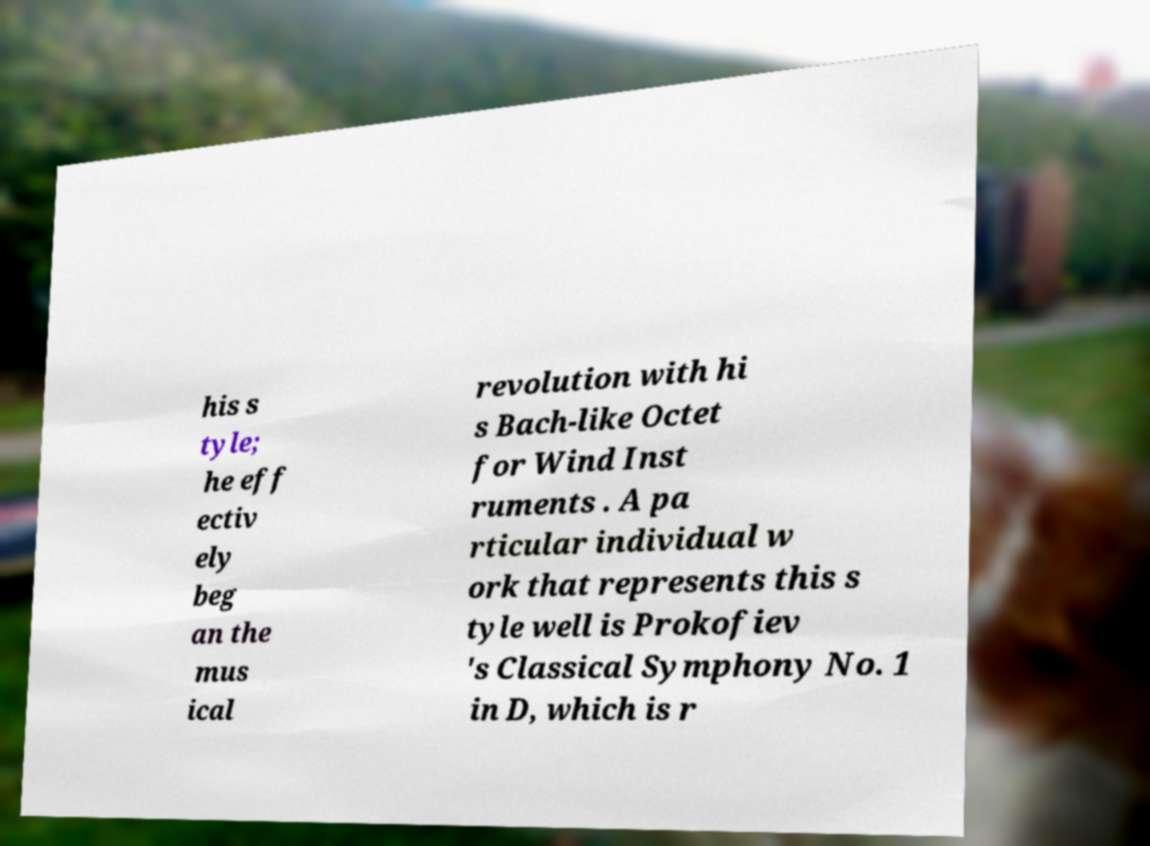Can you read and provide the text displayed in the image?This photo seems to have some interesting text. Can you extract and type it out for me? his s tyle; he eff ectiv ely beg an the mus ical revolution with hi s Bach-like Octet for Wind Inst ruments . A pa rticular individual w ork that represents this s tyle well is Prokofiev 's Classical Symphony No. 1 in D, which is r 